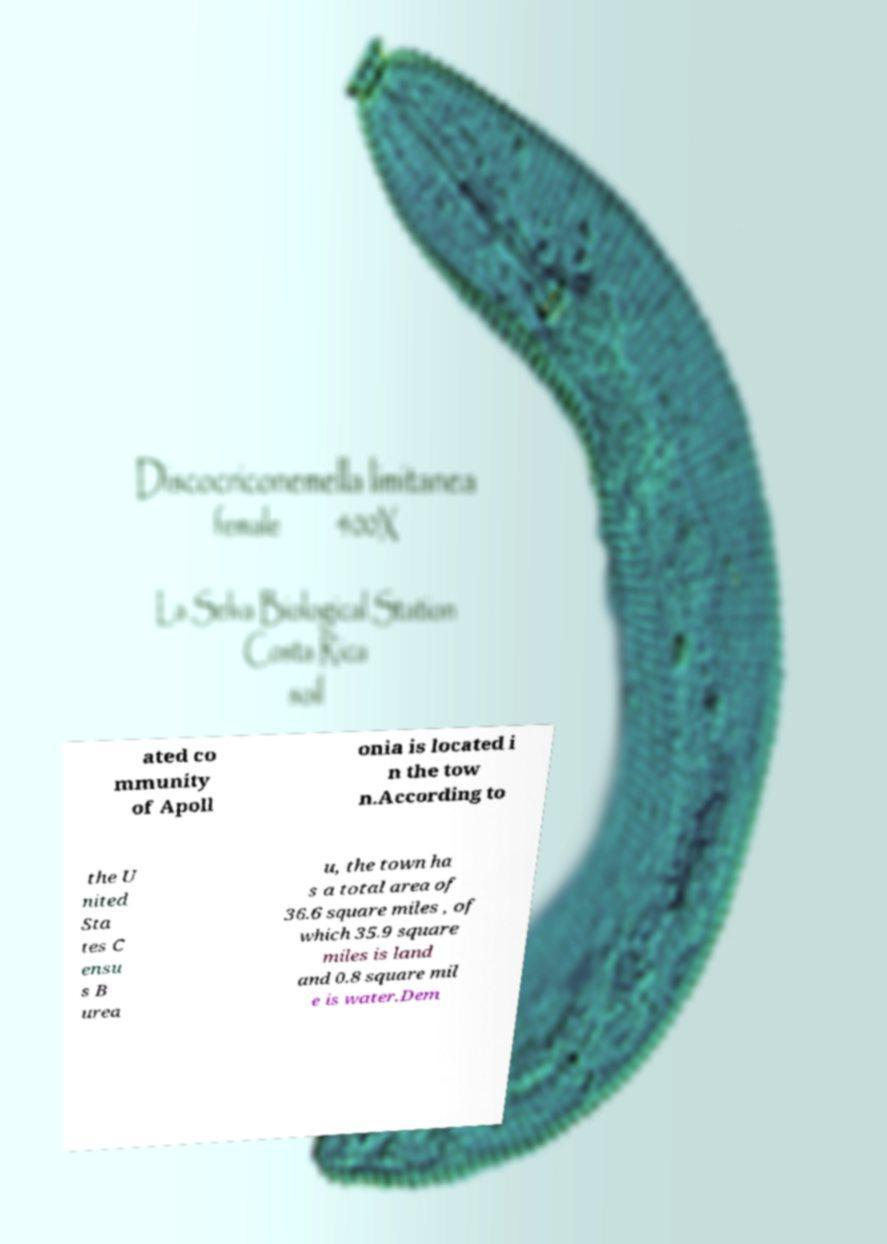Could you extract and type out the text from this image? ated co mmunity of Apoll onia is located i n the tow n.According to the U nited Sta tes C ensu s B urea u, the town ha s a total area of 36.6 square miles , of which 35.9 square miles is land and 0.8 square mil e is water.Dem 